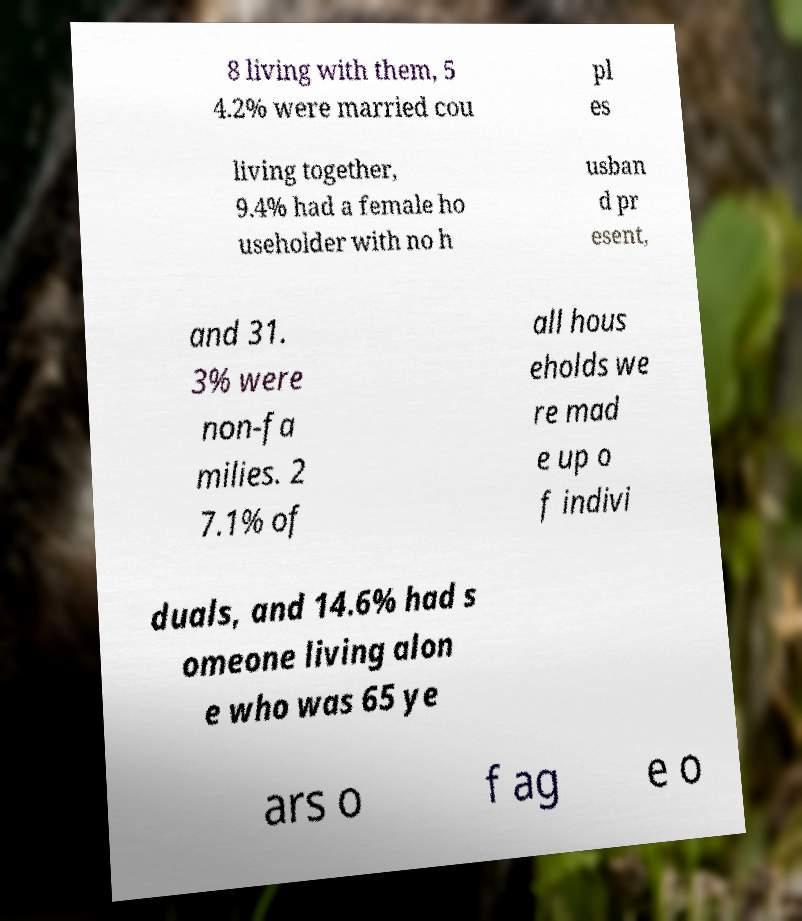What messages or text are displayed in this image? I need them in a readable, typed format. 8 living with them, 5 4.2% were married cou pl es living together, 9.4% had a female ho useholder with no h usban d pr esent, and 31. 3% were non-fa milies. 2 7.1% of all hous eholds we re mad e up o f indivi duals, and 14.6% had s omeone living alon e who was 65 ye ars o f ag e o 